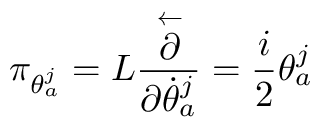<formula> <loc_0><loc_0><loc_500><loc_500>\pi _ { \theta _ { a } ^ { j } } = L \frac { \stackrel { \leftarrow } { \partial } } { \partial \dot { \theta } _ { a } ^ { j } } = \frac { i } { 2 } \theta _ { a } ^ { j }</formula> 